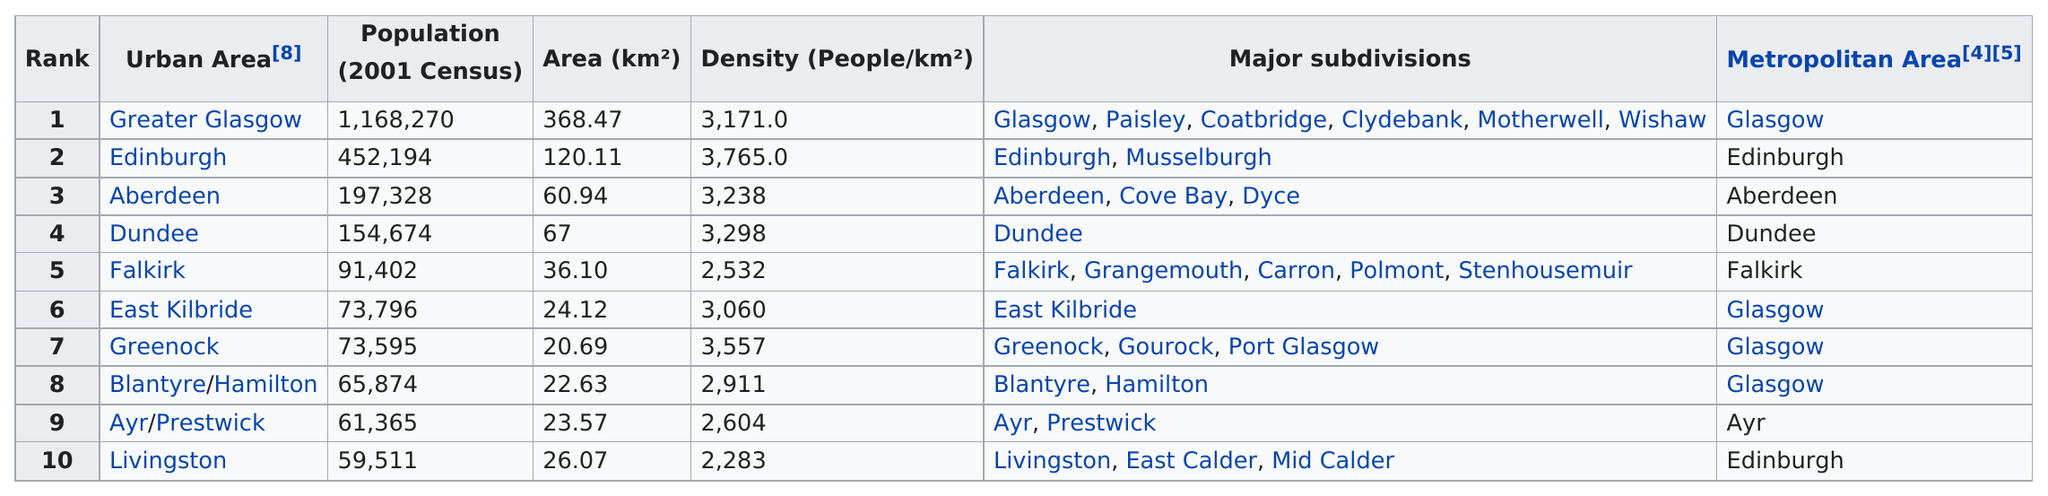Specify some key components in this picture. Dundee is not ranked in the top third of its population. Livingston is the urban area with the least people per square kilometer. There are six urban areas in the United States that have a population under 100,000. Greater Glasgow has a higher population density than Falkirk. Based on the provided information, there are five urban areas that have a population above 90,000. 